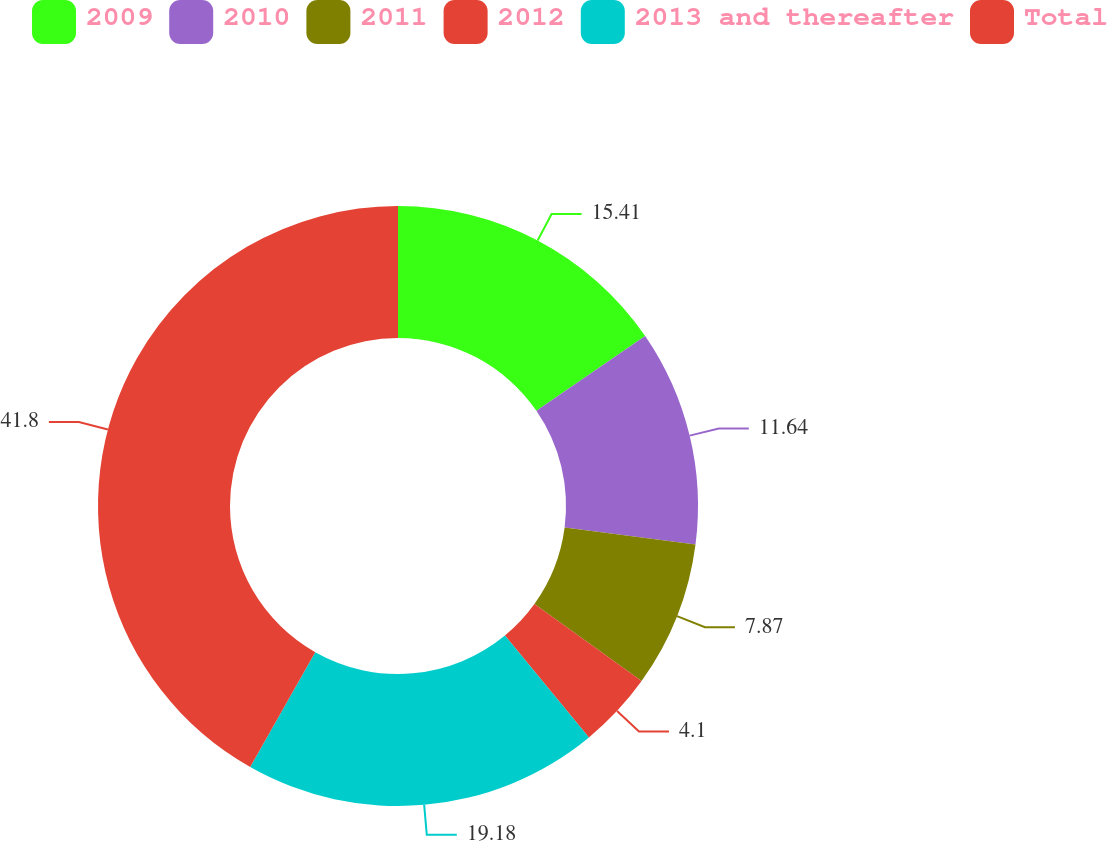Convert chart to OTSL. <chart><loc_0><loc_0><loc_500><loc_500><pie_chart><fcel>2009<fcel>2010<fcel>2011<fcel>2012<fcel>2013 and thereafter<fcel>Total<nl><fcel>15.41%<fcel>11.64%<fcel>7.87%<fcel>4.1%<fcel>19.18%<fcel>41.8%<nl></chart> 